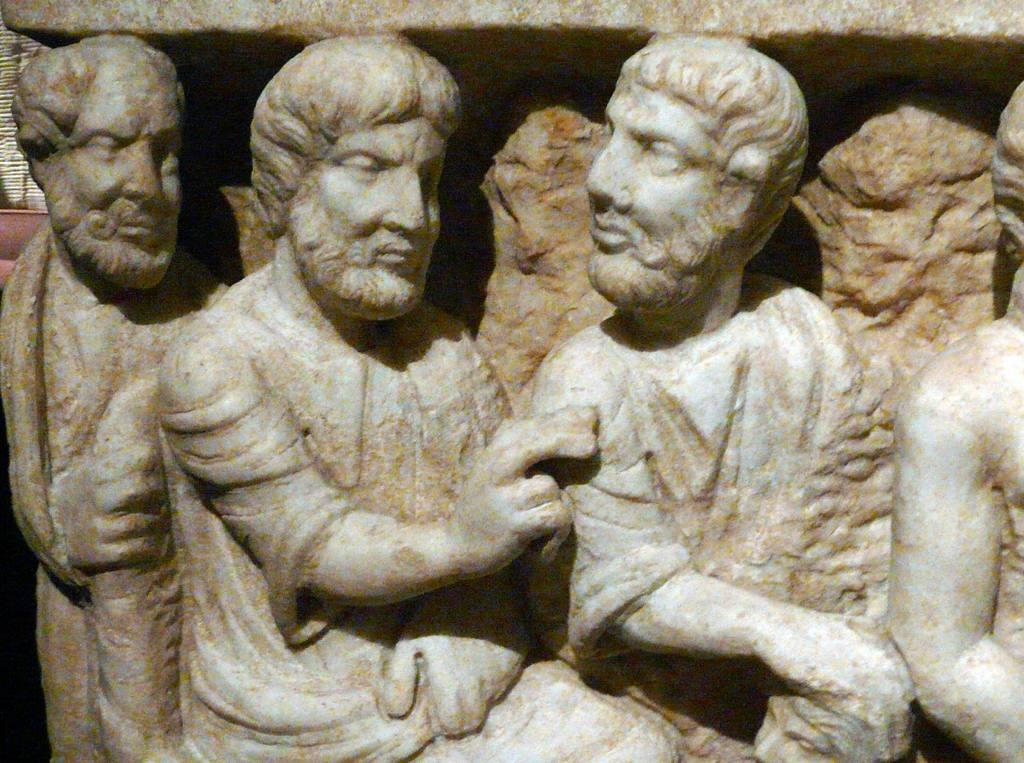What type of objects are depicted in the image? There are sculptures of persons in the image. How many deer can be seen in the image? There are no deer present in the image; it features sculptures of persons. What is the material of the floor in the image? The provided facts do not mention the floor or its material, so it cannot be determined from the image. 